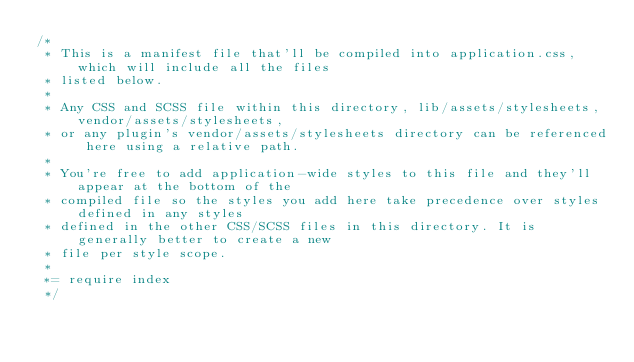Convert code to text. <code><loc_0><loc_0><loc_500><loc_500><_CSS_>/*
 * This is a manifest file that'll be compiled into application.css, which will include all the files
 * listed below.
 *
 * Any CSS and SCSS file within this directory, lib/assets/stylesheets, vendor/assets/stylesheets,
 * or any plugin's vendor/assets/stylesheets directory can be referenced here using a relative path.
 *
 * You're free to add application-wide styles to this file and they'll appear at the bottom of the
 * compiled file so the styles you add here take precedence over styles defined in any styles
 * defined in the other CSS/SCSS files in this directory. It is generally better to create a new
 * file per style scope.
 *
 *= require index
 */
</code> 